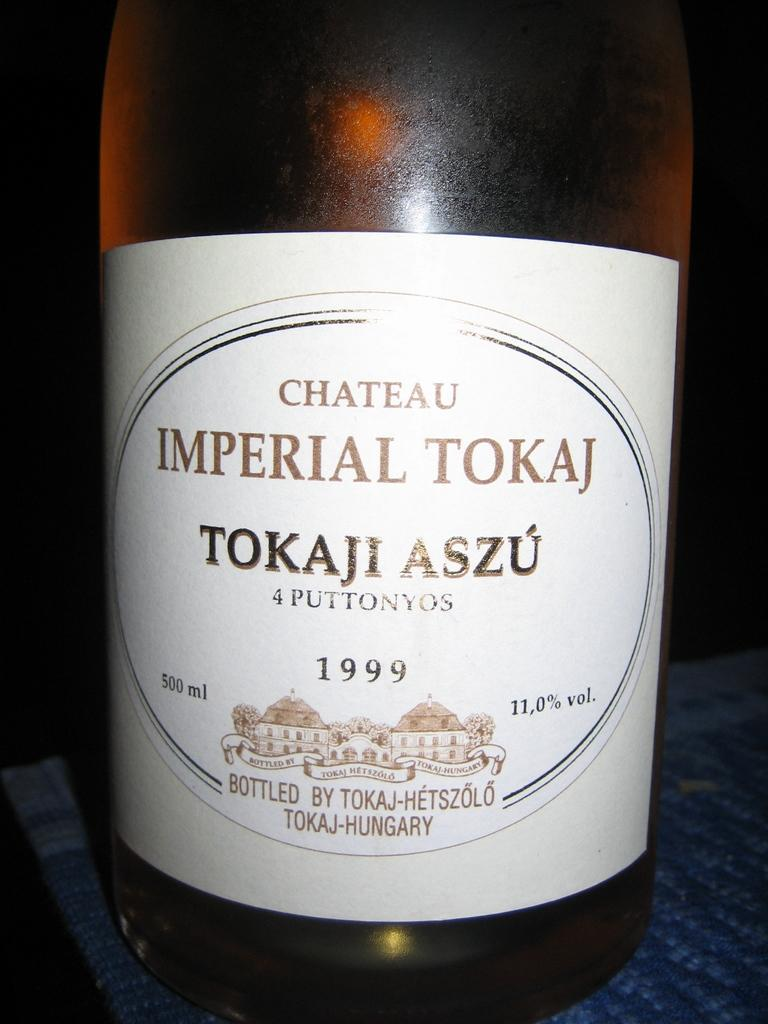<image>
Provide a brief description of the given image. A bottle of alcohol which bears the date 1999. 